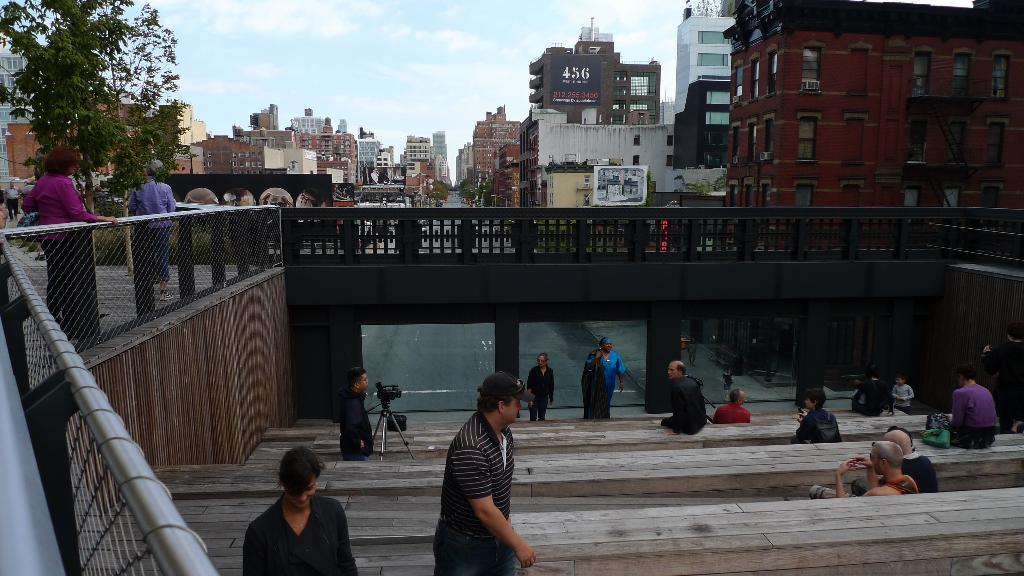How many people can be seen in the image? There are many people in the image. What is the man with in the image? The man has a camera in the image. What can be seen in the background of the image? There is a tree and multiple buildings in the background of the image. What color is the sky in the background of the image? The sky is blue in the background of the image. Are there any bears visible in the image? No, there are no bears present in the image. Can you tell me how the bomb explodes in the image? There is no bomb present in the image, so it cannot explode. 